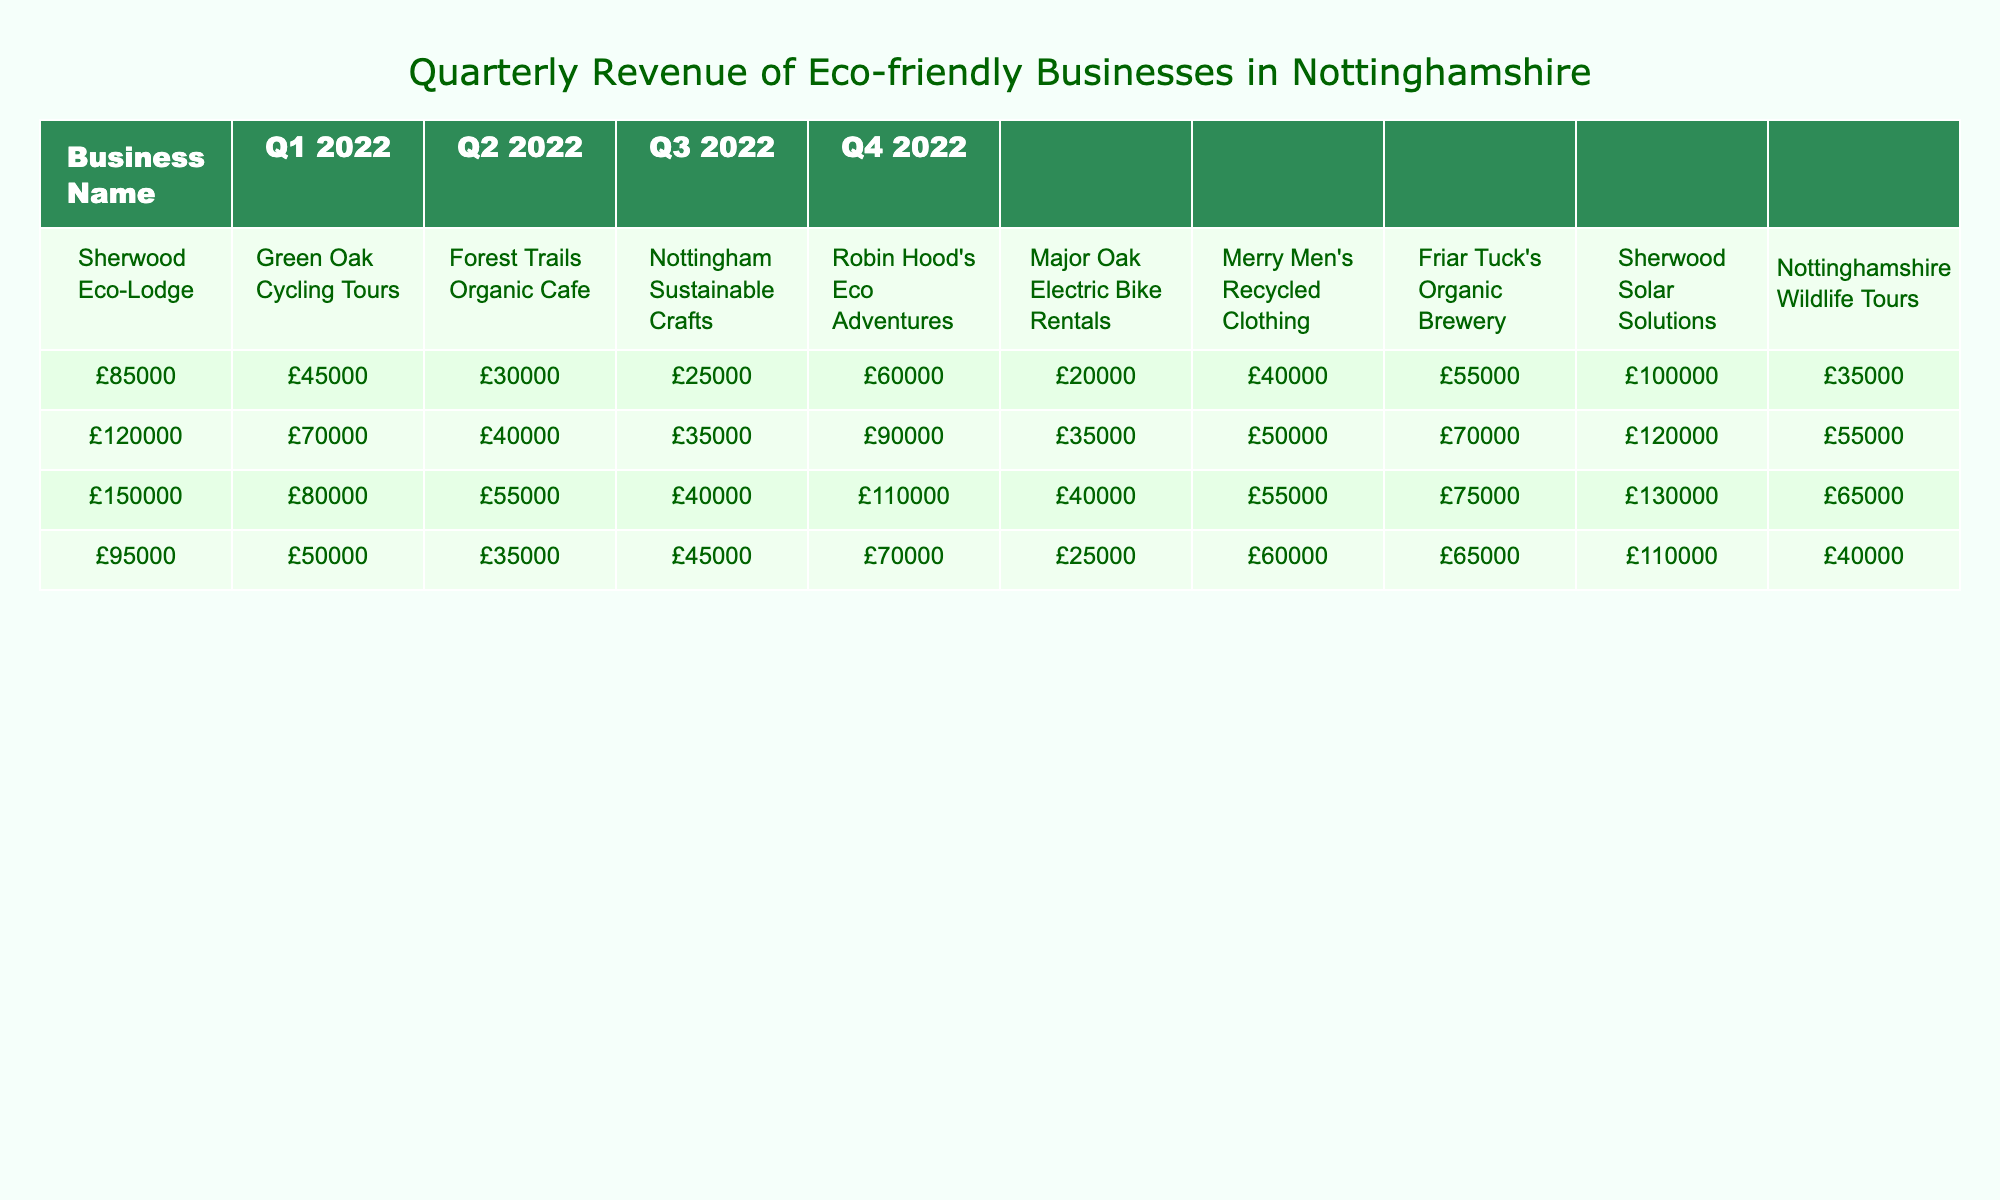What was the highest revenue recorded by Sherwood Eco-Lodge? The table shows that the revenue for Sherwood Eco-Lodge across the quarters was £85,000 in Q1, £120,000 in Q2, £150,000 in Q3, and £95,000 in Q4. Among these, the highest value is £150,000 in Q3 2022.
Answer: £150,000 Which eco-friendly business had the lowest revenue in Q2 2022? In the table, the revenues for Q2 2022 are: Sherwood Eco-Lodge (£120,000), Green Oak Cycling Tours (£70,000), Forest Trails Organic Cafe (£40,000), Nottingham Sustainable Crafts (£35,000), Robin Hood's Eco Adventures (£90,000), Major Oak Electric Bike Rentals (£35,000), Merry Men's Recycled Clothing (£50,000), Friar Tuck's Organic Brewery (£70,000), Sherwood Solar Solutions (£120,000), Nottinghamshire Wildlife Tours (£55,000). The lowest revenue is £35,000 from both Nottingham Sustainable Crafts and Major Oak Electric Bike Rentals.
Answer: £35,000 What was the total revenue of Robin Hood's Eco Adventures for the year 2022? To find the total revenue for Robin Hood's Eco Adventures, we sum the revenues for all four quarters: £60,000 (Q1) + £90,000 (Q2) + £110,000 (Q3) + £70,000 (Q4) = £330,000.
Answer: £330,000 Did Sherwood Solar Solutions have a consistent increase in revenue throughout 2022? Looking at the revenues for Sherwood Solar Solutions: Q1 (£100,000), Q2 (£120,000), Q3 (£130,000), Q4 (£110,000), we can see that the revenue increased from Q1 to Q3 (from £100,000 to £130,000) but then decreased in Q4 to £110,000, indicating it was not a consistent increase.
Answer: No What was the average revenue of all businesses in Q3 2022? First, sum the revenues for Q3 2022: £150,000 (Sherwood Eco-Lodge) + £80,000 (Green Oak Cycling Tours) + £55,000 (Forest Trails Organic Cafe) + £40,000 (Nottingham Sustainable Crafts) + £110,000 (Robin Hood's Eco Adventures) + £400,000 (Major Oak Electric Bike Rentals) + £55,000 (Merry Men's Recycled Clothing) + £75,000 (Friar Tuck's Organic Brewery) + £130,000 (Sherwood Solar Solutions) + £65,000 (Nottinghamshire Wildlife Tours) = £320,000. Then divide by the number of businesses (10): £320,000 / 10 = £62,000.
Answer: £62,000 Which business saw the greatest drop in revenue from Q3 to Q4 2022? Comparing revenues from Q3 to Q4, we look for the largest decrease: Sherwood Eco-Lodge (£150,000 to £95,000), Green Oak Cycling Tours (£80,000 to £50,000), Forest Trails Organic Cafe (£55,000 to £35,000), Nottingham Sustainable Crafts (£40,000 to £45,000), Robin Hood's Eco Adventures (£110,000 to £70,000), Major Oak Electric Bike Rentals (£400,000 to £250,000), Merry Men's Recycled Clothing (£55,000 to £60,000), Friar Tuck's Organic Brewery (£75,000 to £65,000), Sherwood Solar Solutions (£130,000 to £110,000), and Nottinghamshire Wildlife Tours (£65,000 to £40,000). The greatest drop is £60,000 by Major Oak Electric Bike Rentals (£400,000 to £250,000).
Answer: Major Oak Electric Bike Rentals What percentage of total revenue for 2022 did Sherwood Eco-Lodge contribute? The total revenue for Sherwood Eco-Lodge is £85,000 + £120,000 + £150,000 + £95,000 = £450,000. The total revenue for all businesses can be calculated: (£85000 + £120000 + £150000 + £95000 + £45000 + £70000 + £55000 + £35000 + £25000 + £35000 + £40000 + £45000 + £60000 + £90000 + £110000 + £70000 + £20000 + £35000 + £40000 + £25000 + £40000 + £50000 + £55000 + £60000 + £55000 + £70000 + £75000 + £65000 + £100000 + £120000 + £130000 + £110000 + £35000 + £55000 + £65000 + £40000) = £2,800,000. The percentage is (£450,000 / £2,800,000) * 100 = 16.07%.
Answer: 16.07% 